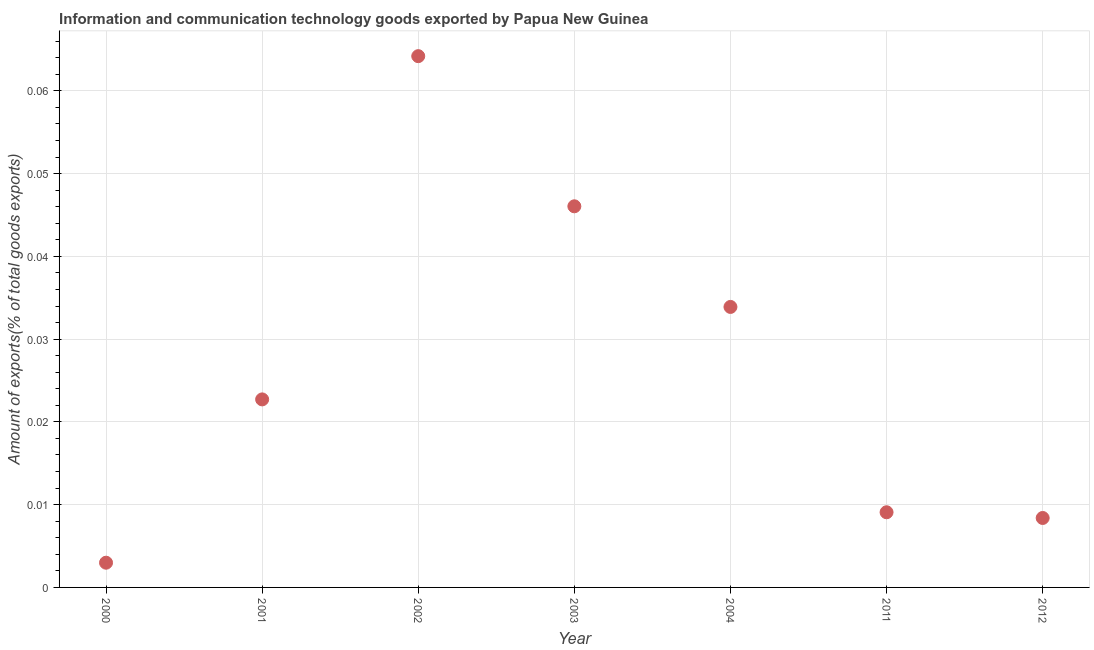What is the amount of ict goods exports in 2004?
Keep it short and to the point. 0.03. Across all years, what is the maximum amount of ict goods exports?
Keep it short and to the point. 0.06. Across all years, what is the minimum amount of ict goods exports?
Give a very brief answer. 0. In which year was the amount of ict goods exports maximum?
Provide a succinct answer. 2002. In which year was the amount of ict goods exports minimum?
Your response must be concise. 2000. What is the sum of the amount of ict goods exports?
Ensure brevity in your answer.  0.19. What is the difference between the amount of ict goods exports in 2003 and 2012?
Offer a terse response. 0.04. What is the average amount of ict goods exports per year?
Make the answer very short. 0.03. What is the median amount of ict goods exports?
Offer a very short reply. 0.02. In how many years, is the amount of ict goods exports greater than 0.064 %?
Provide a succinct answer. 1. Do a majority of the years between 2012 and 2002 (inclusive) have amount of ict goods exports greater than 0.014 %?
Make the answer very short. Yes. What is the ratio of the amount of ict goods exports in 2001 to that in 2011?
Make the answer very short. 2.5. Is the difference between the amount of ict goods exports in 2002 and 2012 greater than the difference between any two years?
Provide a short and direct response. No. What is the difference between the highest and the second highest amount of ict goods exports?
Offer a terse response. 0.02. What is the difference between the highest and the lowest amount of ict goods exports?
Ensure brevity in your answer.  0.06. Does the amount of ict goods exports monotonically increase over the years?
Provide a short and direct response. No. How many dotlines are there?
Provide a succinct answer. 1. How many years are there in the graph?
Your response must be concise. 7. What is the difference between two consecutive major ticks on the Y-axis?
Offer a terse response. 0.01. Does the graph contain any zero values?
Provide a short and direct response. No. What is the title of the graph?
Offer a very short reply. Information and communication technology goods exported by Papua New Guinea. What is the label or title of the X-axis?
Provide a short and direct response. Year. What is the label or title of the Y-axis?
Your response must be concise. Amount of exports(% of total goods exports). What is the Amount of exports(% of total goods exports) in 2000?
Make the answer very short. 0. What is the Amount of exports(% of total goods exports) in 2001?
Keep it short and to the point. 0.02. What is the Amount of exports(% of total goods exports) in 2002?
Give a very brief answer. 0.06. What is the Amount of exports(% of total goods exports) in 2003?
Provide a succinct answer. 0.05. What is the Amount of exports(% of total goods exports) in 2004?
Offer a very short reply. 0.03. What is the Amount of exports(% of total goods exports) in 2011?
Ensure brevity in your answer.  0.01. What is the Amount of exports(% of total goods exports) in 2012?
Your response must be concise. 0.01. What is the difference between the Amount of exports(% of total goods exports) in 2000 and 2001?
Your answer should be compact. -0.02. What is the difference between the Amount of exports(% of total goods exports) in 2000 and 2002?
Offer a terse response. -0.06. What is the difference between the Amount of exports(% of total goods exports) in 2000 and 2003?
Provide a succinct answer. -0.04. What is the difference between the Amount of exports(% of total goods exports) in 2000 and 2004?
Provide a succinct answer. -0.03. What is the difference between the Amount of exports(% of total goods exports) in 2000 and 2011?
Make the answer very short. -0.01. What is the difference between the Amount of exports(% of total goods exports) in 2000 and 2012?
Ensure brevity in your answer.  -0.01. What is the difference between the Amount of exports(% of total goods exports) in 2001 and 2002?
Provide a succinct answer. -0.04. What is the difference between the Amount of exports(% of total goods exports) in 2001 and 2003?
Your answer should be very brief. -0.02. What is the difference between the Amount of exports(% of total goods exports) in 2001 and 2004?
Your answer should be compact. -0.01. What is the difference between the Amount of exports(% of total goods exports) in 2001 and 2011?
Give a very brief answer. 0.01. What is the difference between the Amount of exports(% of total goods exports) in 2001 and 2012?
Offer a terse response. 0.01. What is the difference between the Amount of exports(% of total goods exports) in 2002 and 2003?
Ensure brevity in your answer.  0.02. What is the difference between the Amount of exports(% of total goods exports) in 2002 and 2004?
Your answer should be compact. 0.03. What is the difference between the Amount of exports(% of total goods exports) in 2002 and 2011?
Your answer should be compact. 0.06. What is the difference between the Amount of exports(% of total goods exports) in 2002 and 2012?
Make the answer very short. 0.06. What is the difference between the Amount of exports(% of total goods exports) in 2003 and 2004?
Your response must be concise. 0.01. What is the difference between the Amount of exports(% of total goods exports) in 2003 and 2011?
Your answer should be compact. 0.04. What is the difference between the Amount of exports(% of total goods exports) in 2003 and 2012?
Keep it short and to the point. 0.04. What is the difference between the Amount of exports(% of total goods exports) in 2004 and 2011?
Provide a succinct answer. 0.02. What is the difference between the Amount of exports(% of total goods exports) in 2004 and 2012?
Offer a very short reply. 0.03. What is the difference between the Amount of exports(% of total goods exports) in 2011 and 2012?
Provide a succinct answer. 0. What is the ratio of the Amount of exports(% of total goods exports) in 2000 to that in 2001?
Your answer should be very brief. 0.13. What is the ratio of the Amount of exports(% of total goods exports) in 2000 to that in 2002?
Keep it short and to the point. 0.05. What is the ratio of the Amount of exports(% of total goods exports) in 2000 to that in 2003?
Provide a succinct answer. 0.07. What is the ratio of the Amount of exports(% of total goods exports) in 2000 to that in 2004?
Make the answer very short. 0.09. What is the ratio of the Amount of exports(% of total goods exports) in 2000 to that in 2011?
Give a very brief answer. 0.33. What is the ratio of the Amount of exports(% of total goods exports) in 2000 to that in 2012?
Keep it short and to the point. 0.36. What is the ratio of the Amount of exports(% of total goods exports) in 2001 to that in 2002?
Make the answer very short. 0.35. What is the ratio of the Amount of exports(% of total goods exports) in 2001 to that in 2003?
Your answer should be compact. 0.49. What is the ratio of the Amount of exports(% of total goods exports) in 2001 to that in 2004?
Your answer should be very brief. 0.67. What is the ratio of the Amount of exports(% of total goods exports) in 2001 to that in 2011?
Provide a succinct answer. 2.5. What is the ratio of the Amount of exports(% of total goods exports) in 2001 to that in 2012?
Offer a terse response. 2.71. What is the ratio of the Amount of exports(% of total goods exports) in 2002 to that in 2003?
Provide a succinct answer. 1.39. What is the ratio of the Amount of exports(% of total goods exports) in 2002 to that in 2004?
Provide a succinct answer. 1.89. What is the ratio of the Amount of exports(% of total goods exports) in 2002 to that in 2011?
Offer a very short reply. 7.07. What is the ratio of the Amount of exports(% of total goods exports) in 2002 to that in 2012?
Provide a succinct answer. 7.65. What is the ratio of the Amount of exports(% of total goods exports) in 2003 to that in 2004?
Provide a short and direct response. 1.36. What is the ratio of the Amount of exports(% of total goods exports) in 2003 to that in 2011?
Provide a succinct answer. 5.07. What is the ratio of the Amount of exports(% of total goods exports) in 2003 to that in 2012?
Give a very brief answer. 5.49. What is the ratio of the Amount of exports(% of total goods exports) in 2004 to that in 2011?
Make the answer very short. 3.73. What is the ratio of the Amount of exports(% of total goods exports) in 2004 to that in 2012?
Your answer should be very brief. 4.04. What is the ratio of the Amount of exports(% of total goods exports) in 2011 to that in 2012?
Provide a succinct answer. 1.08. 